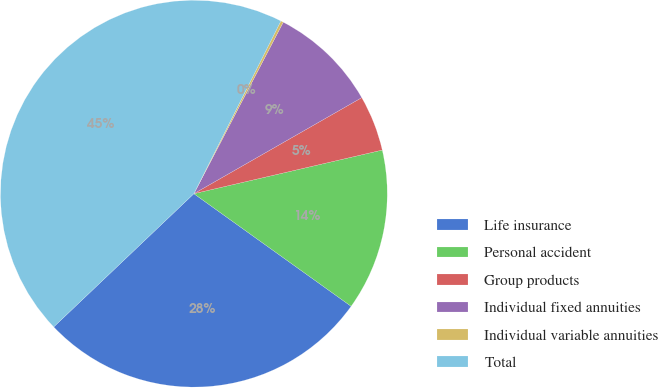Convert chart to OTSL. <chart><loc_0><loc_0><loc_500><loc_500><pie_chart><fcel>Life insurance<fcel>Personal accident<fcel>Group products<fcel>Individual fixed annuities<fcel>Individual variable annuities<fcel>Total<nl><fcel>28.01%<fcel>13.51%<fcel>4.65%<fcel>9.08%<fcel>0.22%<fcel>44.52%<nl></chart> 